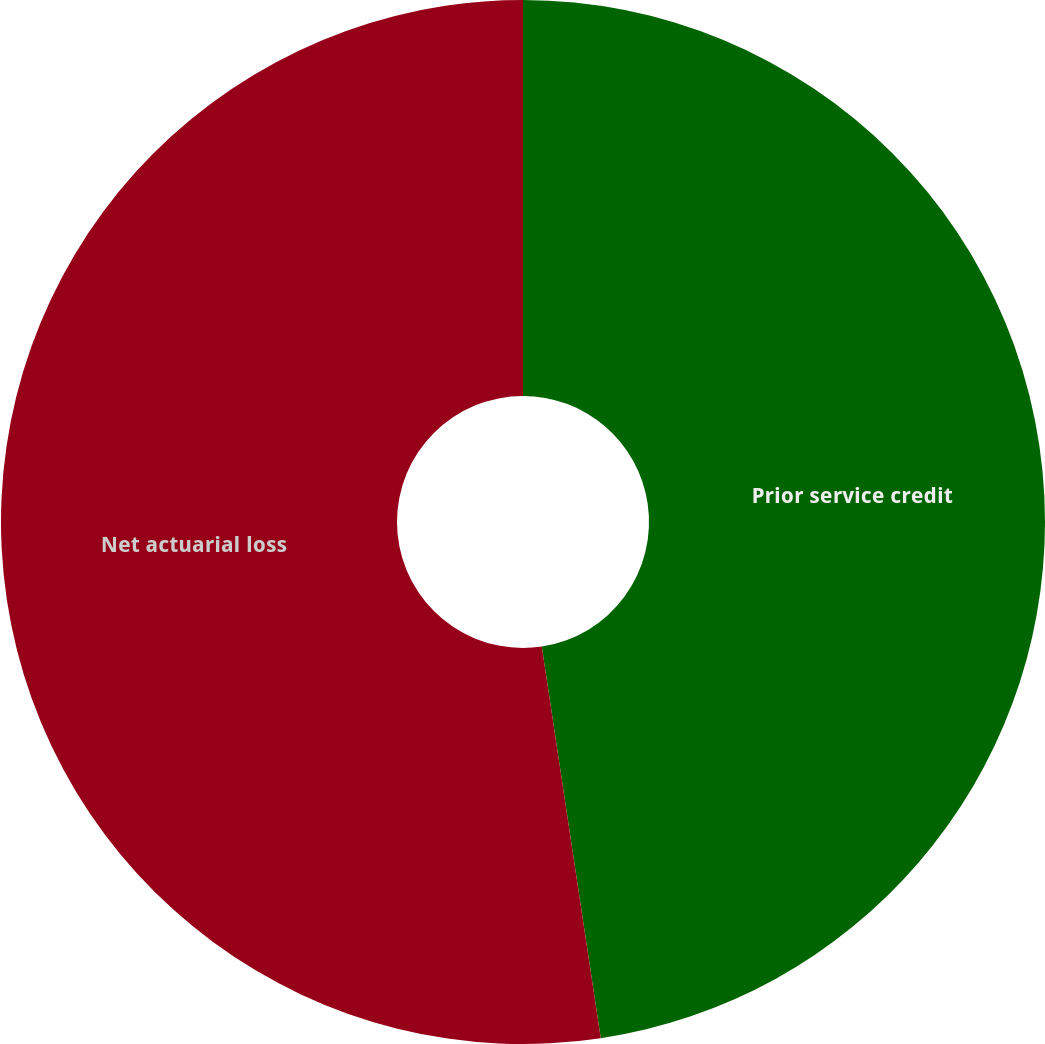<chart> <loc_0><loc_0><loc_500><loc_500><pie_chart><fcel>Prior service credit<fcel>Net actuarial loss<nl><fcel>47.62%<fcel>52.38%<nl></chart> 